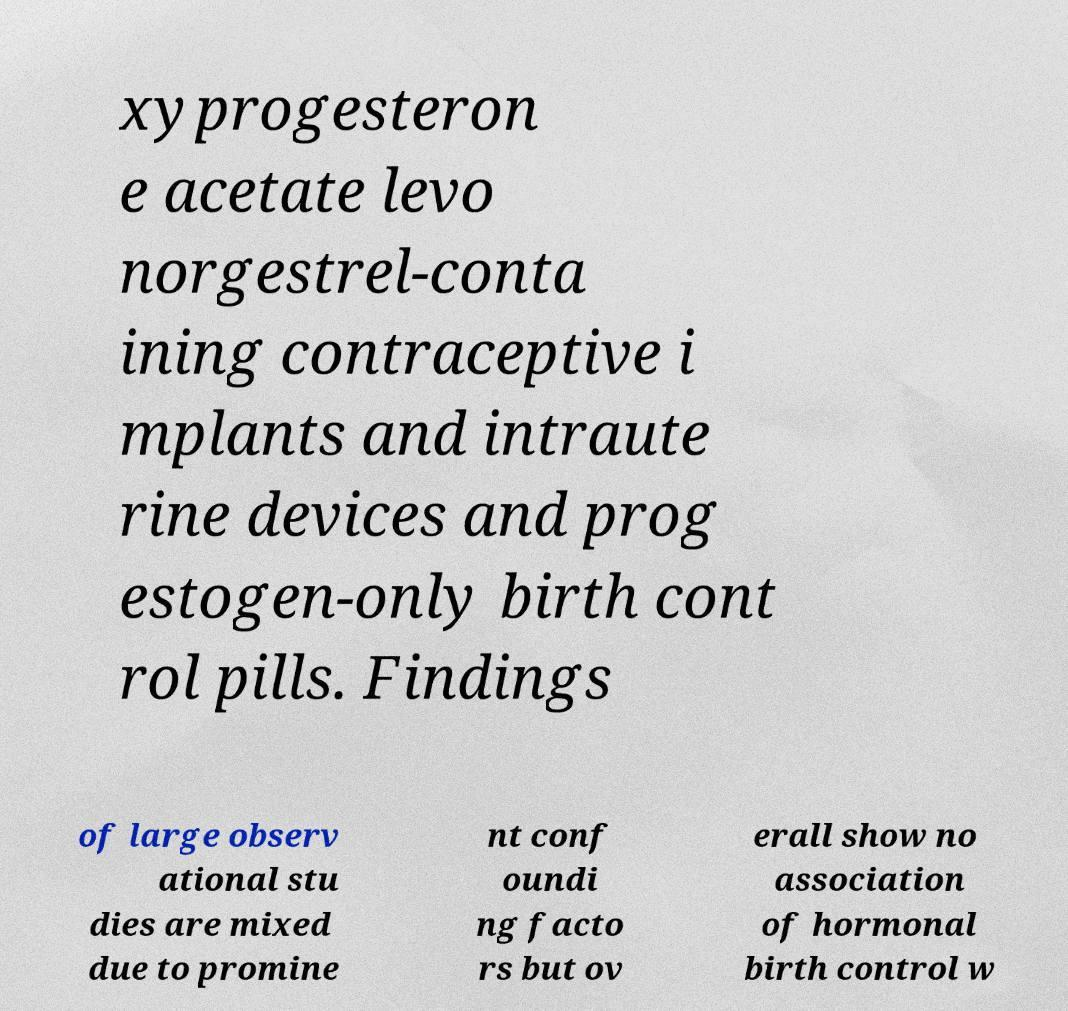Can you accurately transcribe the text from the provided image for me? xyprogesteron e acetate levo norgestrel-conta ining contraceptive i mplants and intraute rine devices and prog estogen-only birth cont rol pills. Findings of large observ ational stu dies are mixed due to promine nt conf oundi ng facto rs but ov erall show no association of hormonal birth control w 